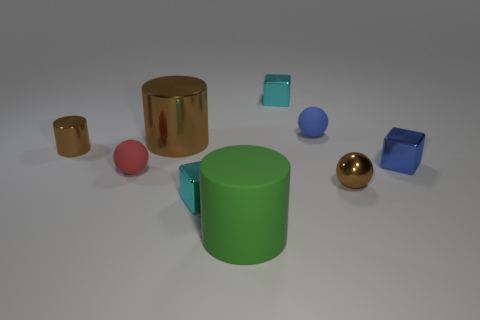How many cyan cubes must be subtracted to get 1 cyan cubes? 1 Subtract all balls. How many objects are left? 6 Add 2 blue metal things. How many blue metal things exist? 3 Subtract 0 purple spheres. How many objects are left? 9 Subtract all small rubber balls. Subtract all brown objects. How many objects are left? 4 Add 3 red balls. How many red balls are left? 4 